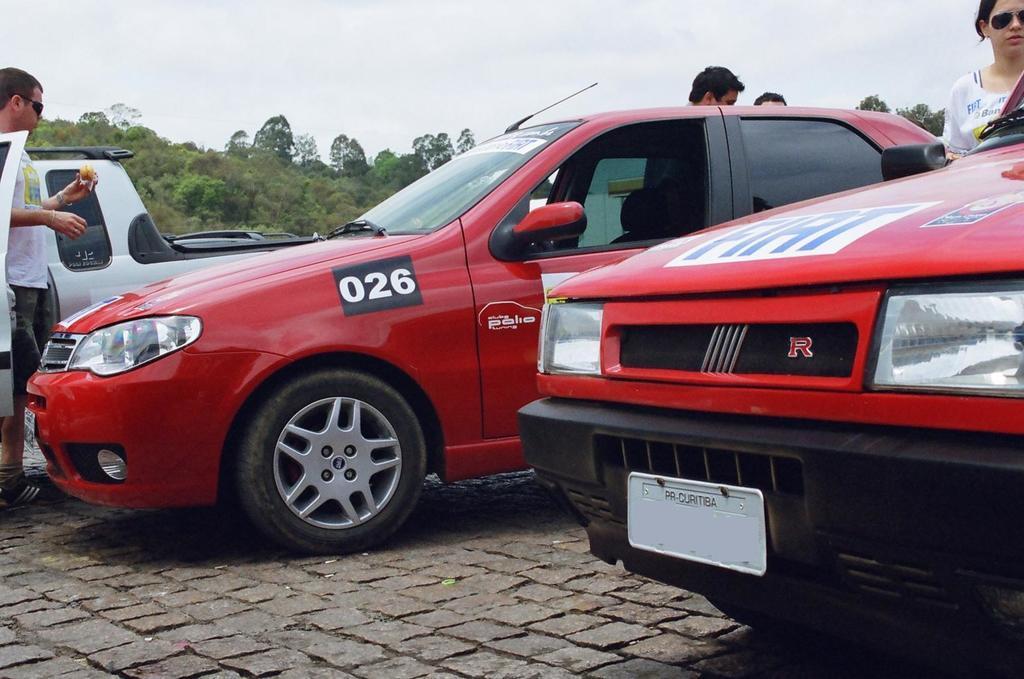In one or two sentences, can you explain what this image depicts? In this image there is a red colour car in the middle and there are two other cars on either side of it. On the left side there is a man standing near the car. In the background there are trees. At the top there is sky. On the right side there is a woman near the car. 